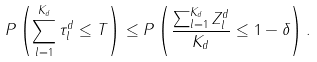Convert formula to latex. <formula><loc_0><loc_0><loc_500><loc_500>P \left ( \sum _ { l = 1 } ^ { K _ { d } } \tau ^ { d } _ { l } \leq T \right ) \leq P \left ( \frac { \sum _ { l = 1 } ^ { K _ { d } } Z _ { l } ^ { d } } { K _ { d } } \leq 1 - \delta \right ) .</formula> 